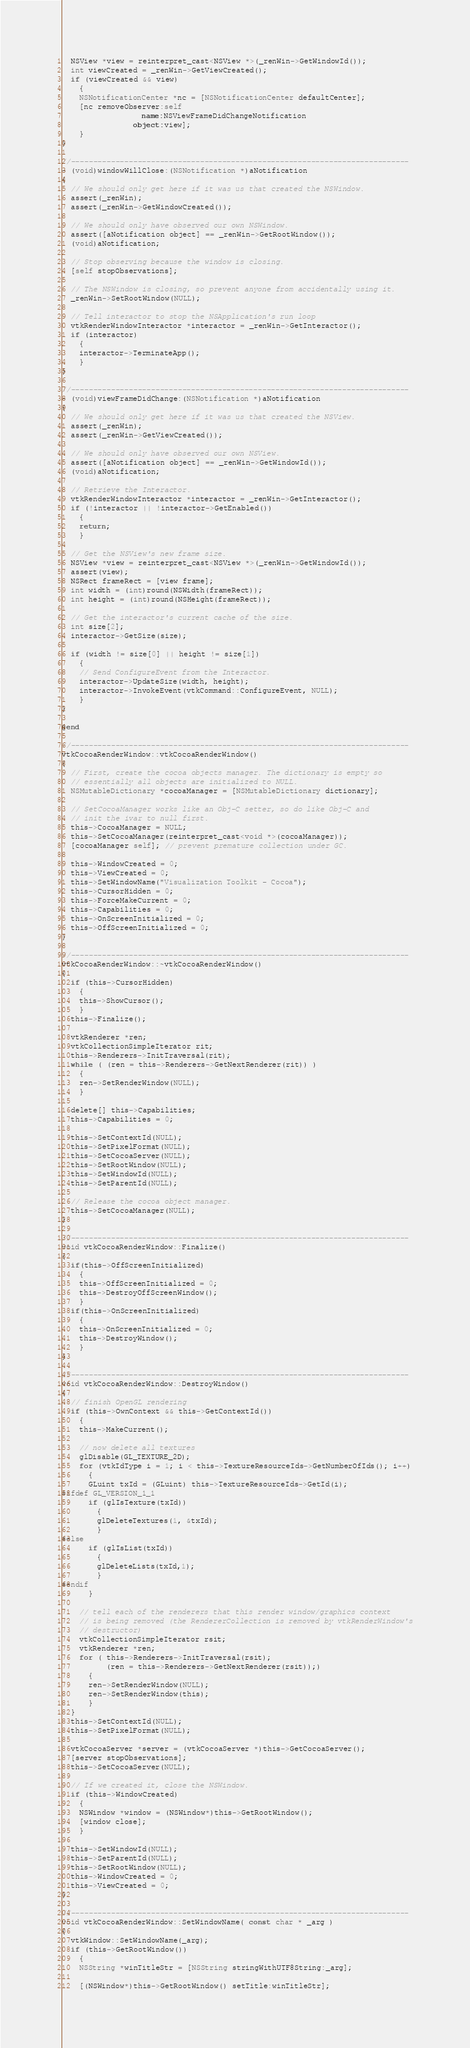Convert code to text. <code><loc_0><loc_0><loc_500><loc_500><_ObjectiveC_>
  NSView *view = reinterpret_cast<NSView *>(_renWin->GetWindowId());
  int viewCreated = _renWin->GetViewCreated();
  if (viewCreated && view)
    {
    NSNotificationCenter *nc = [NSNotificationCenter defaultCenter];
    [nc removeObserver:self
                  name:NSViewFrameDidChangeNotification
                object:view];
    }
}

//----------------------------------------------------------------------------
- (void)windowWillClose:(NSNotification *)aNotification
{
  // We should only get here if it was us that created the NSWindow.
  assert(_renWin);
  assert(_renWin->GetWindowCreated());

  // We should only have observed our own NSWindow.
  assert([aNotification object] == _renWin->GetRootWindow());
  (void)aNotification;

  // Stop observing because the window is closing.
  [self stopObservations];

  // The NSWindow is closing, so prevent anyone from accidentally using it.
  _renWin->SetRootWindow(NULL);

  // Tell interactor to stop the NSApplication's run loop
  vtkRenderWindowInteractor *interactor = _renWin->GetInteractor();
  if (interactor)
    {
    interactor->TerminateApp();
    }
}

//----------------------------------------------------------------------------
- (void)viewFrameDidChange:(NSNotification *)aNotification
{
  // We should only get here if it was us that created the NSView.
  assert(_renWin);
  assert(_renWin->GetViewCreated());

  // We should only have observed our own NSView.
  assert([aNotification object] == _renWin->GetWindowId());
  (void)aNotification;

  // Retrieve the Interactor.
  vtkRenderWindowInteractor *interactor = _renWin->GetInteractor();
  if (!interactor || !interactor->GetEnabled())
    {
    return;
    }

  // Get the NSView's new frame size.
  NSView *view = reinterpret_cast<NSView *>(_renWin->GetWindowId());
  assert(view);
  NSRect frameRect = [view frame];
  int width = (int)round(NSWidth(frameRect));
  int height = (int)round(NSHeight(frameRect));

  // Get the interactor's current cache of the size.
  int size[2];
  interactor->GetSize(size);

  if (width != size[0] || height != size[1])
    {
    // Send ConfigureEvent from the Interactor.
    interactor->UpdateSize(width, height);
    interactor->InvokeEvent(vtkCommand::ConfigureEvent, NULL);
    }
}

@end

//----------------------------------------------------------------------------
vtkCocoaRenderWindow::vtkCocoaRenderWindow()
{
  // First, create the cocoa objects manager. The dictionary is empty so
  // essentially all objects are initialized to NULL.
  NSMutableDictionary *cocoaManager = [NSMutableDictionary dictionary];

  // SetCocoaManager works like an Obj-C setter, so do like Obj-C and
  // init the ivar to null first.
  this->CocoaManager = NULL;
  this->SetCocoaManager(reinterpret_cast<void *>(cocoaManager));
  [cocoaManager self]; // prevent premature collection under GC.

  this->WindowCreated = 0;
  this->ViewCreated = 0;
  this->SetWindowName("Visualization Toolkit - Cocoa");
  this->CursorHidden = 0;
  this->ForceMakeCurrent = 0;
  this->Capabilities = 0;
  this->OnScreenInitialized = 0;
  this->OffScreenInitialized = 0;
}

//----------------------------------------------------------------------------
vtkCocoaRenderWindow::~vtkCocoaRenderWindow()
{
  if (this->CursorHidden)
    {
    this->ShowCursor();
    }
  this->Finalize();

  vtkRenderer *ren;
  vtkCollectionSimpleIterator rit;
  this->Renderers->InitTraversal(rit);
  while ( (ren = this->Renderers->GetNextRenderer(rit)) )
    {
    ren->SetRenderWindow(NULL);
    }

  delete[] this->Capabilities;
  this->Capabilities = 0;

  this->SetContextId(NULL);
  this->SetPixelFormat(NULL);
  this->SetCocoaServer(NULL);
  this->SetRootWindow(NULL);
  this->SetWindowId(NULL);
  this->SetParentId(NULL);

  // Release the cocoa object manager.
  this->SetCocoaManager(NULL);
}

//----------------------------------------------------------------------------
void vtkCocoaRenderWindow::Finalize()
{
  if(this->OffScreenInitialized)
    {
    this->OffScreenInitialized = 0;
    this->DestroyOffScreenWindow();
    }
  if(this->OnScreenInitialized)
    {
    this->OnScreenInitialized = 0;
    this->DestroyWindow();
    }
}

//----------------------------------------------------------------------------
void vtkCocoaRenderWindow::DestroyWindow()
{
  // finish OpenGL rendering
  if (this->OwnContext && this->GetContextId())
    {
    this->MakeCurrent();

    // now delete all textures
    glDisable(GL_TEXTURE_2D);
    for (vtkIdType i = 1; i < this->TextureResourceIds->GetNumberOfIds(); i++)
      {
      GLuint txId = (GLuint) this->TextureResourceIds->GetId(i);
#ifdef GL_VERSION_1_1
      if (glIsTexture(txId))
        {
        glDeleteTextures(1, &txId);
        }
#else
      if (glIsList(txId))
        {
        glDeleteLists(txId,1);
        }
#endif
      }

    // tell each of the renderers that this render window/graphics context
    // is being removed (the RendererCollection is removed by vtkRenderWindow's
    // destructor)
    vtkCollectionSimpleIterator rsit;
    vtkRenderer *ren;
    for ( this->Renderers->InitTraversal(rsit);
          (ren = this->Renderers->GetNextRenderer(rsit));)
      {
      ren->SetRenderWindow(NULL);
      ren->SetRenderWindow(this);
      }
  }
  this->SetContextId(NULL);
  this->SetPixelFormat(NULL);

  vtkCocoaServer *server = (vtkCocoaServer *)this->GetCocoaServer();
  [server stopObservations];
  this->SetCocoaServer(NULL);

  // If we created it, close the NSWindow.
  if (this->WindowCreated)
    {
    NSWindow *window = (NSWindow*)this->GetRootWindow();
    [window close];
    }

  this->SetWindowId(NULL);
  this->SetParentId(NULL);
  this->SetRootWindow(NULL);
  this->WindowCreated = 0;
  this->ViewCreated = 0;
}

//----------------------------------------------------------------------------
void vtkCocoaRenderWindow::SetWindowName( const char * _arg )
{
  vtkWindow::SetWindowName(_arg);
  if (this->GetRootWindow())
    {
    NSString *winTitleStr = [NSString stringWithUTF8String:_arg];

    [(NSWindow*)this->GetRootWindow() setTitle:winTitleStr];</code> 